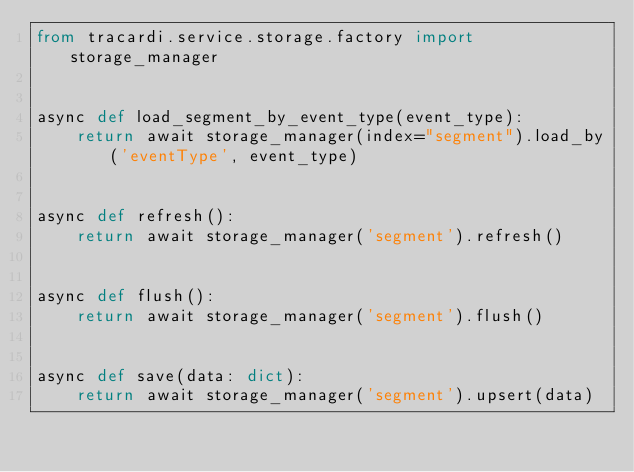Convert code to text. <code><loc_0><loc_0><loc_500><loc_500><_Python_>from tracardi.service.storage.factory import storage_manager


async def load_segment_by_event_type(event_type):
    return await storage_manager(index="segment").load_by('eventType', event_type)


async def refresh():
    return await storage_manager('segment').refresh()


async def flush():
    return await storage_manager('segment').flush()


async def save(data: dict):
    return await storage_manager('segment').upsert(data)
</code> 